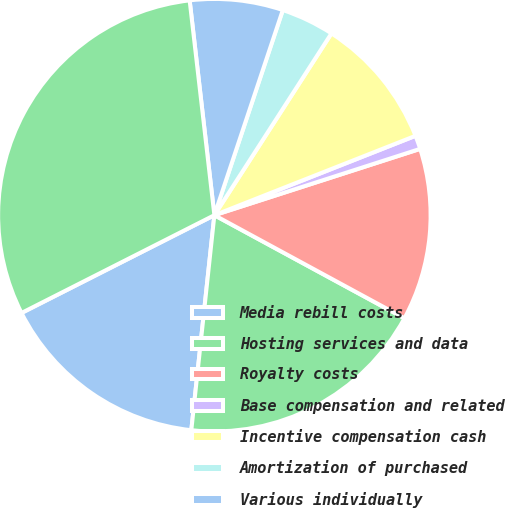Convert chart. <chart><loc_0><loc_0><loc_500><loc_500><pie_chart><fcel>Media rebill costs<fcel>Hosting services and data<fcel>Royalty costs<fcel>Base compensation and related<fcel>Incentive compensation cash<fcel>Amortization of purchased<fcel>Various individually<fcel>Total change<nl><fcel>15.83%<fcel>18.79%<fcel>12.87%<fcel>1.02%<fcel>9.91%<fcel>3.98%<fcel>6.95%<fcel>30.64%<nl></chart> 